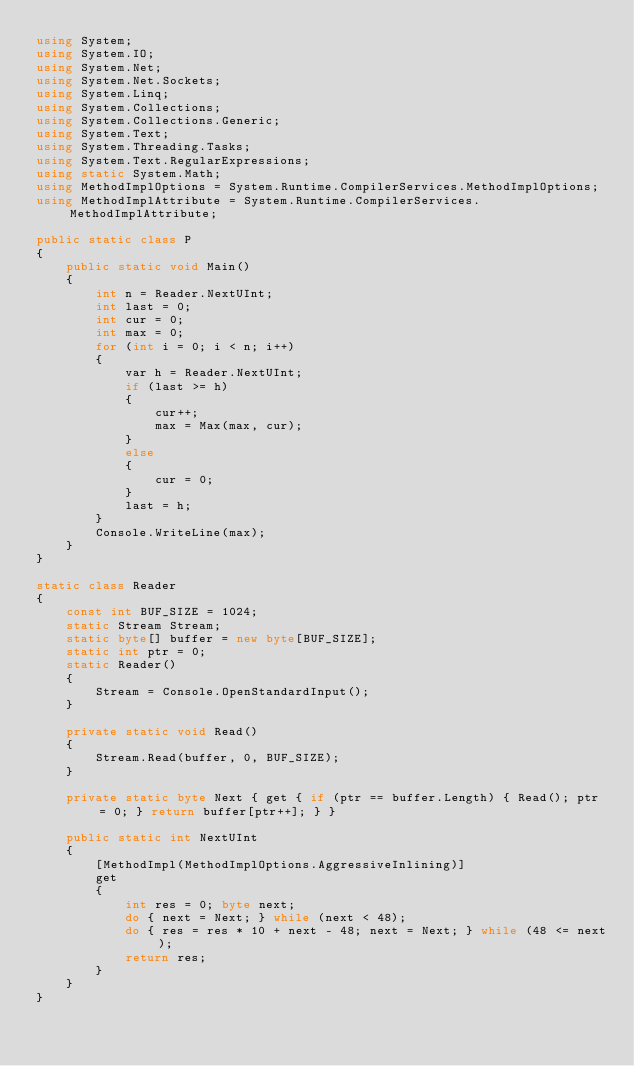Convert code to text. <code><loc_0><loc_0><loc_500><loc_500><_C#_>using System;
using System.IO;
using System.Net;
using System.Net.Sockets;
using System.Linq;
using System.Collections;
using System.Collections.Generic;
using System.Text;
using System.Threading.Tasks;
using System.Text.RegularExpressions;
using static System.Math;
using MethodImplOptions = System.Runtime.CompilerServices.MethodImplOptions;
using MethodImplAttribute = System.Runtime.CompilerServices.MethodImplAttribute;

public static class P
{
    public static void Main()
    {
        int n = Reader.NextUInt;
        int last = 0;
        int cur = 0;
        int max = 0;
        for (int i = 0; i < n; i++)
        {
            var h = Reader.NextUInt;
            if (last >= h)
            {
                cur++;
                max = Max(max, cur);
            }
            else
            {
                cur = 0;
            }
            last = h;
        }
        Console.WriteLine(max);
    }
}

static class Reader
{
    const int BUF_SIZE = 1024;
    static Stream Stream;
    static byte[] buffer = new byte[BUF_SIZE];
    static int ptr = 0;
    static Reader()
    {
        Stream = Console.OpenStandardInput();
    }

    private static void Read()
    {
        Stream.Read(buffer, 0, BUF_SIZE);
    }

    private static byte Next { get { if (ptr == buffer.Length) { Read(); ptr = 0; } return buffer[ptr++]; } }

    public static int NextUInt
    {
        [MethodImpl(MethodImplOptions.AggressiveInlining)]
        get
        {
            int res = 0; byte next;
            do { next = Next; } while (next < 48);
            do { res = res * 10 + next - 48; next = Next; } while (48 <= next);
            return res;
        }
    }
}
</code> 